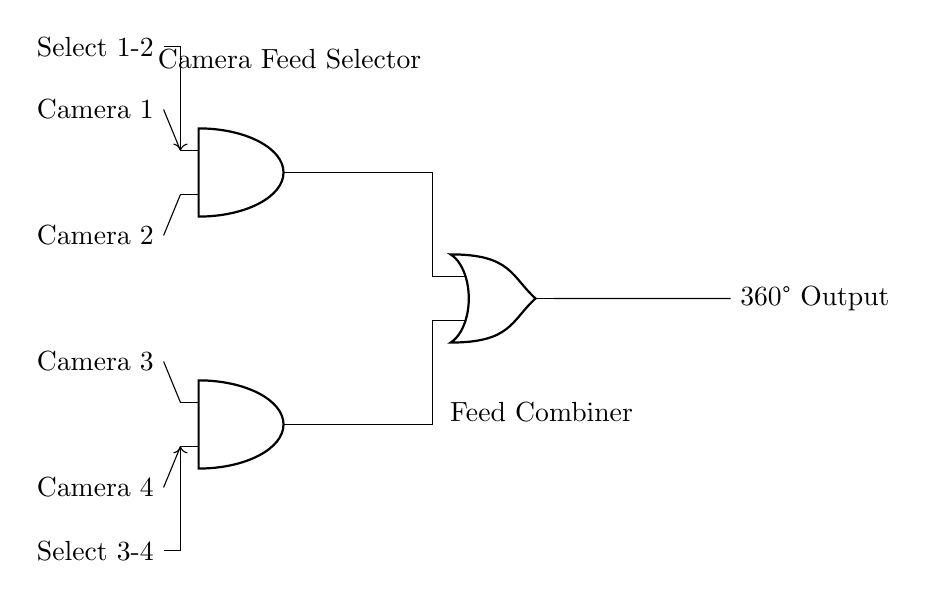What are the types of gates used in this circuit? The circuit contains AND and OR gates. The AND gates process inputs from camera feeds, while the OR gate combines their outputs.
Answer: AND and OR How many camera feeds are connected to the circuit? There are four camera feeds connected to the circuit, labeled Camera 1, Camera 2, Camera 3, and Camera 4.
Answer: Four What is the purpose of the first AND gate? The first AND gate receives inputs from Camera 1 and Camera 2 to select between these two feeds based on the selection signal.
Answer: Selecting cameras 1 and 2 How does the selection control influence the outputs? The selection controls determine which camera feeds (1-2 or 3-4) are allowed to pass through their respective AND gates, affecting which signals are sent to the OR gate for output.
Answer: Determines allowed feeds What is the output of the OR gate connected to? The output of the OR gate is connected to the 360° Output, which likely represents the final combined feed from the selected camera inputs.
Answer: 360° Output 